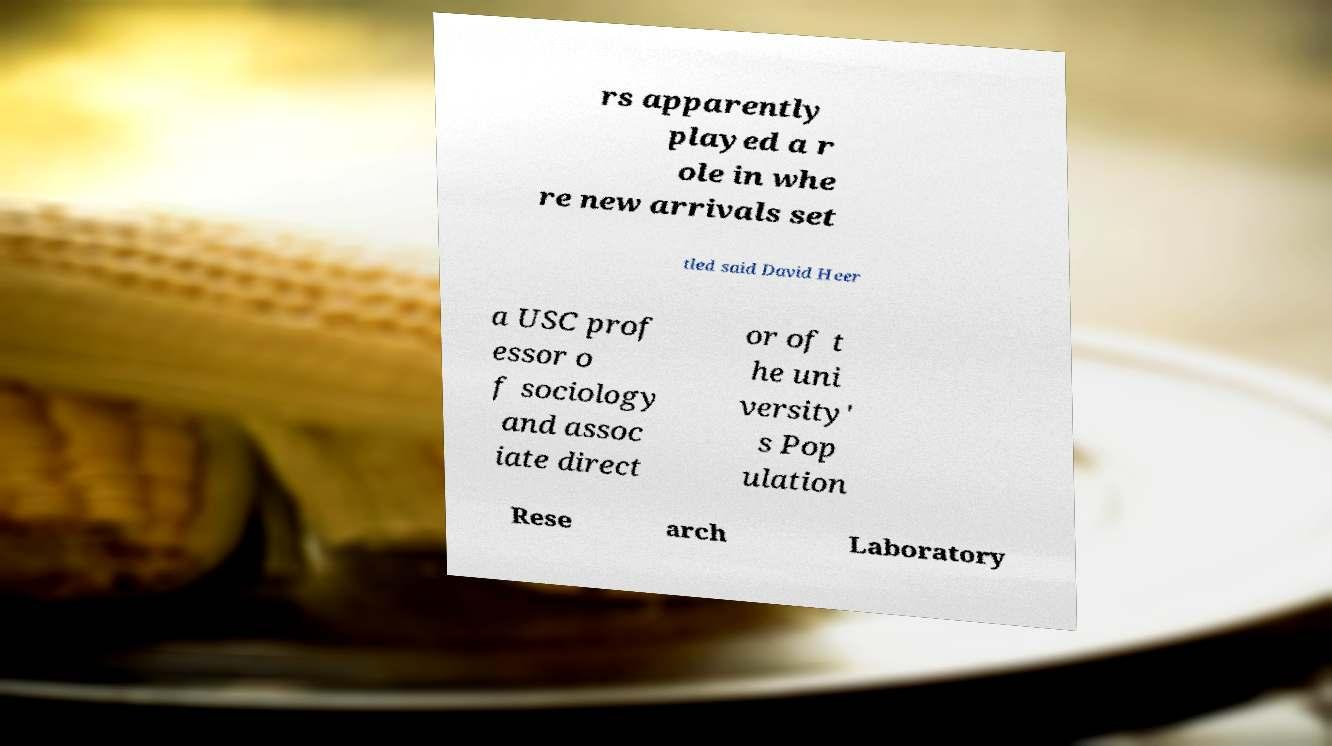Please identify and transcribe the text found in this image. rs apparently played a r ole in whe re new arrivals set tled said David Heer a USC prof essor o f sociology and assoc iate direct or of t he uni versity' s Pop ulation Rese arch Laboratory 